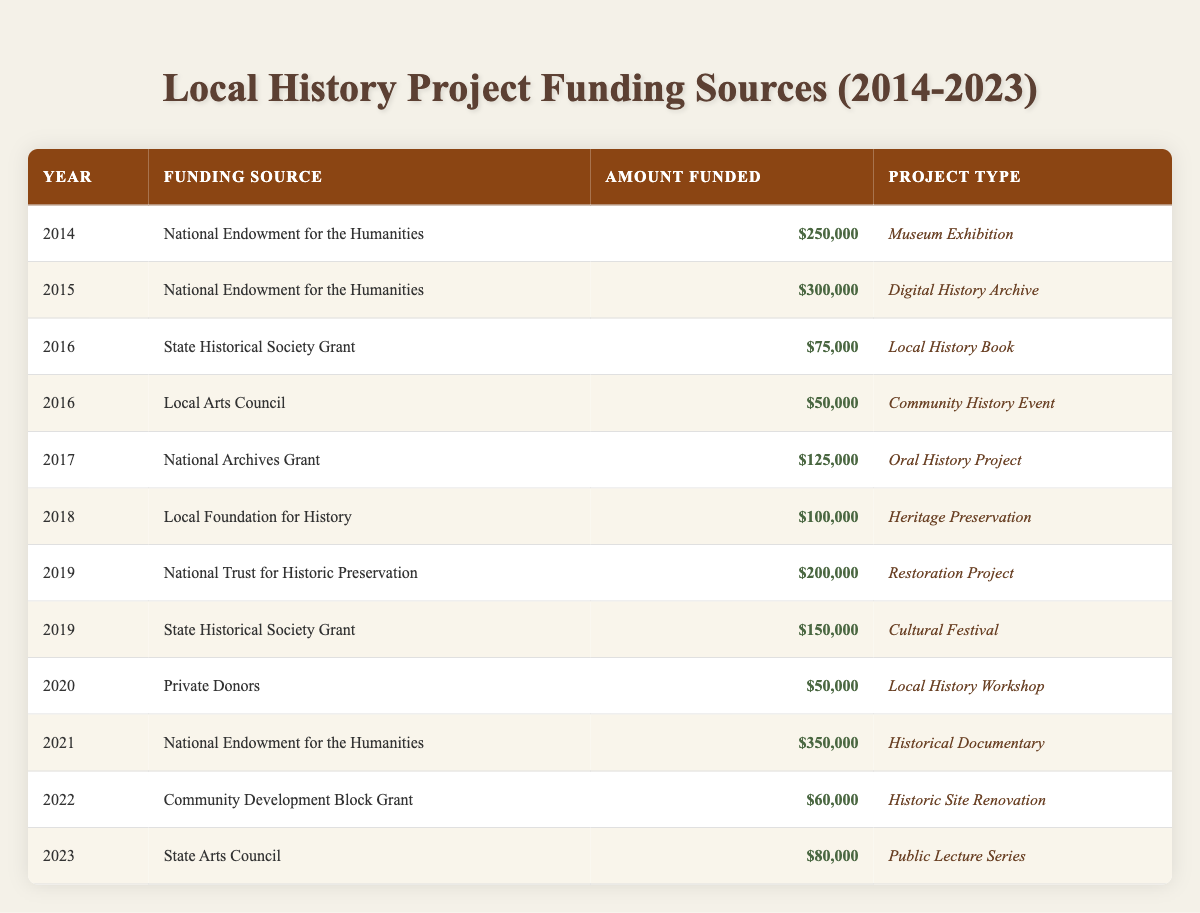What was the total funding amount from the National Endowment for the Humanities over the years recorded? To find the total, I will look for all entries under the National Endowment for the Humanities and sum their funded amounts: 250000 (2014) + 300000 (2015) + 350000 (2021) = 900000.
Answer: 900000 What was the funding amount for the Public Lecture Series in 2023? I can find the Public Lecture Series in the table and see that the funding amount for 2023 is 80000.
Answer: 80000 Is the Local Arts Council a funding source that provided more than 60000 in any year? Looking at the entries, the Local Arts Council provided 50000 in 2016, which is not more than 60000. Therefore, the answer is no.
Answer: No What was the year with the highest funding amount, and what was that amount? I will examine the "Amount Funded" column for the highest value. The highest amount is 350000 from the National Endowment for the Humanities in 2021.
Answer: 2021, 350000 How much total funding was provided for projects in 2019? I need to find amounts for all the projects listed in 2019. There are two entries: 200000 (National Trust for Historic Preservation) and 150000 (State Historical Society Grant). Adding these gives: 200000 + 150000 = 350000.
Answer: 350000 Was there any funding for a Local History Book? Checking the table, there is a funding entry for a Local History Book in 2016 by the State Historical Society Grant. Hence, the answer is yes.
Answer: Yes What was the median funding amount across all projects listed? I need to list all funding amounts in order: 50000, 60000, 75000, 80000, 100000, 125000, 150000, 200000, 250000, 300000, 350000. There are 11 amounts, so the median is the 6th amount which is 100000.
Answer: 100000 Which funding source provided the least amount, and what was that amount? I will look through the amounts provided to find the minimum funding: The smallest amount is 50000 from Private Donors for the Local History Workshop in 2020.
Answer: Private Donors, 50000 